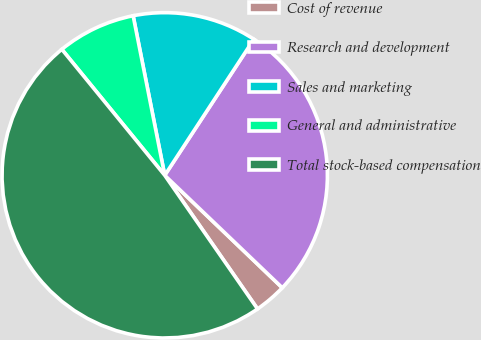Convert chart to OTSL. <chart><loc_0><loc_0><loc_500><loc_500><pie_chart><fcel>Cost of revenue<fcel>Research and development<fcel>Sales and marketing<fcel>General and administrative<fcel>Total stock-based compensation<nl><fcel>3.19%<fcel>27.92%<fcel>12.34%<fcel>7.79%<fcel>48.76%<nl></chart> 